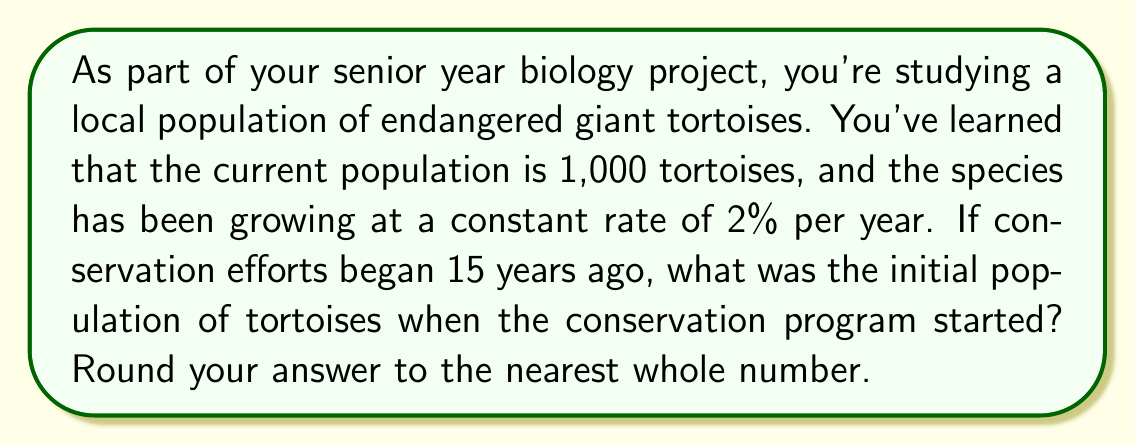Show me your answer to this math problem. Let's approach this step-by-step:

1) Let $P_0$ be the initial population and $P_t$ be the population after $t$ years.

2) The growth rate is 2% per year, so we can express this as $r = 0.02$.

3) We know that after 15 years, the population is 1,000 tortoises.

4) The formula for exponential growth is:

   $P_t = P_0 \cdot (1 + r)^t$

5) Plugging in our known values:

   $1000 = P_0 \cdot (1 + 0.02)^{15}$

6) To solve for $P_0$, we divide both sides by $(1.02)^{15}$:

   $P_0 = \frac{1000}{(1.02)^{15}}$

7) Calculate $(1.02)^{15}$:
   
   $(1.02)^{15} \approx 1.3459$

8) Now we can solve for $P_0$:

   $P_0 = \frac{1000}{1.3459} \approx 742.99$

9) Rounding to the nearest whole number:

   $P_0 \approx 743$
Answer: 743 tortoises 